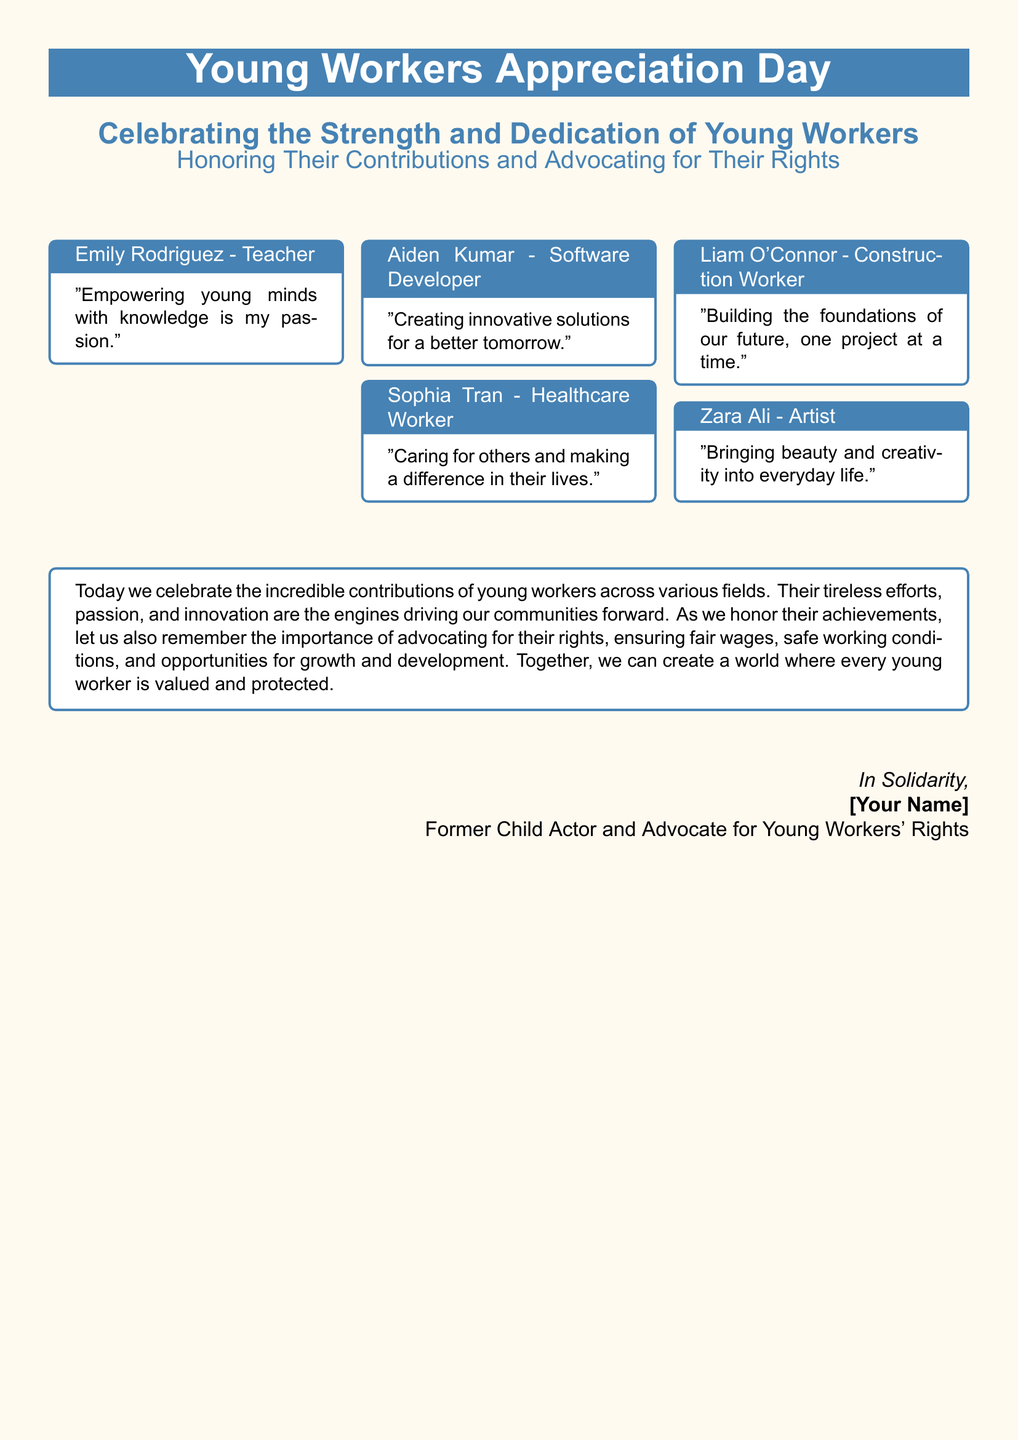What is the theme of the greeting card? The theme of the greeting card is specifically about recognizing and celebrating young workers and their contributions.
Answer: Young Workers Appreciation Day Who is featured as a healthcare worker? The document includes a quote from a young healthcare worker, identifying them as Sophia Tran.
Answer: Sophia Tran What profession does Aiden Kumar belong to? Aiden Kumar's role is clearly specified as a software developer in the document.
Answer: Software Developer How many portraits of different young workers are included? The greeting card features five portraits, representing various professions.
Answer: Five What color is used for the card's header? The header color specified in the document is a shade indicated by its RGB values.
Answer: RGB(70,130,180) What does the document emphasize about young workers' rights? The document emphasizes advocating for fair wages, safe working conditions, and growth opportunities for young workers.
Answer: Advocating for their rights Who is the sender of the card? The signature at the bottom indicates who is sending the card, describing their background.
Answer: [Your Name] What quote represents Liam O'Connor's work? The quote from Liam O'Connor reflects his profession and perspective on his contributions.
Answer: "Building the foundations of our future, one project at a time." 